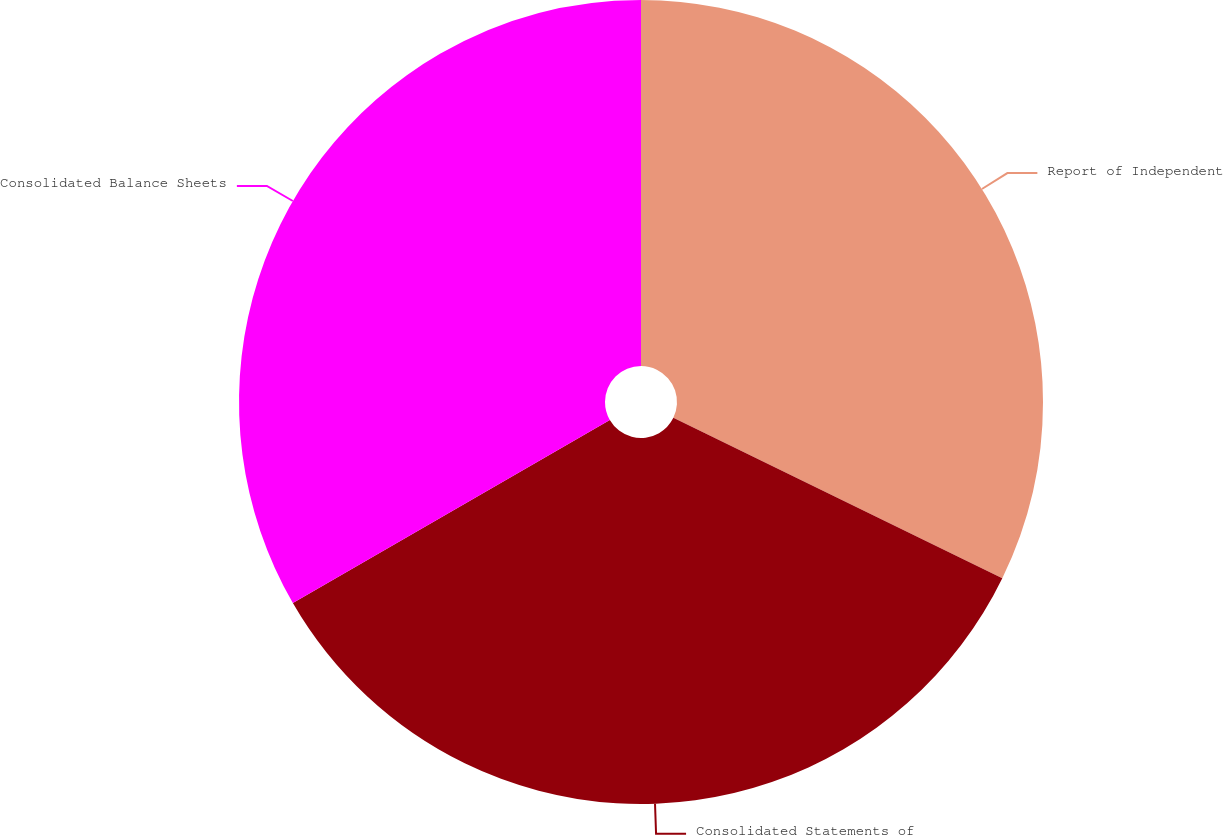Convert chart to OTSL. <chart><loc_0><loc_0><loc_500><loc_500><pie_chart><fcel>Report of Independent<fcel>Consolidated Statements of<fcel>Consolidated Balance Sheets<nl><fcel>32.22%<fcel>34.44%<fcel>33.33%<nl></chart> 